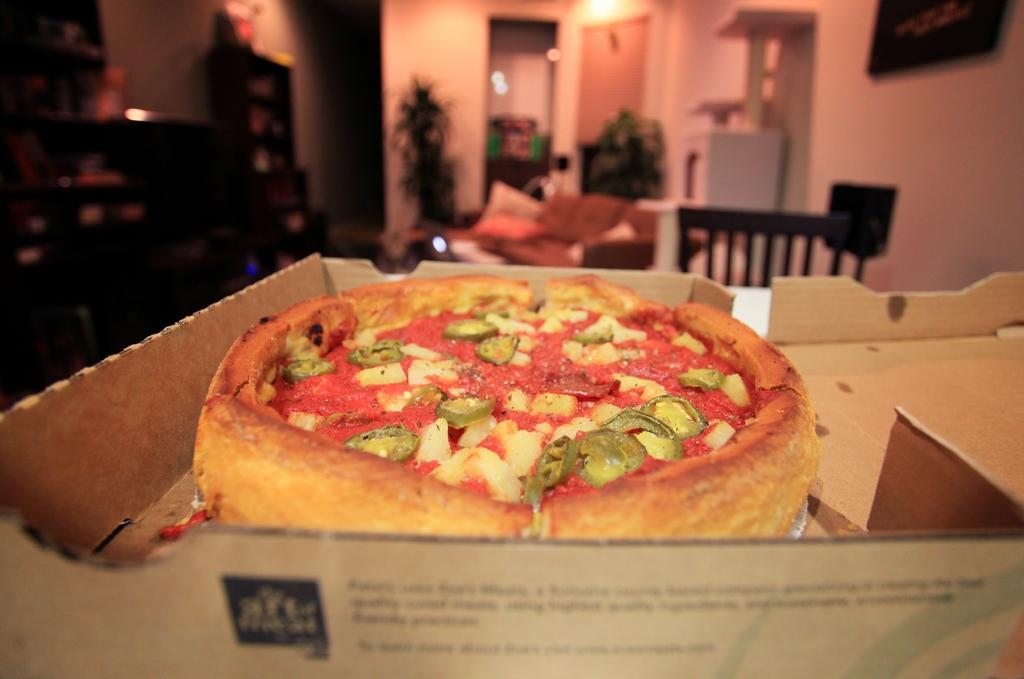What type of food is visible in the image? There is a pizza in the image. Where is the pizza located? The pizza is in a box. Can you describe the background of the image? The background of the image is blurred. What type of rail can be seen supporting the pizza in the image? There is no rail present in the image; it features a pizza in a box. What color is the thread used to hold the pizza in the image? There is no thread present in the image; it features a pizza in a box. 